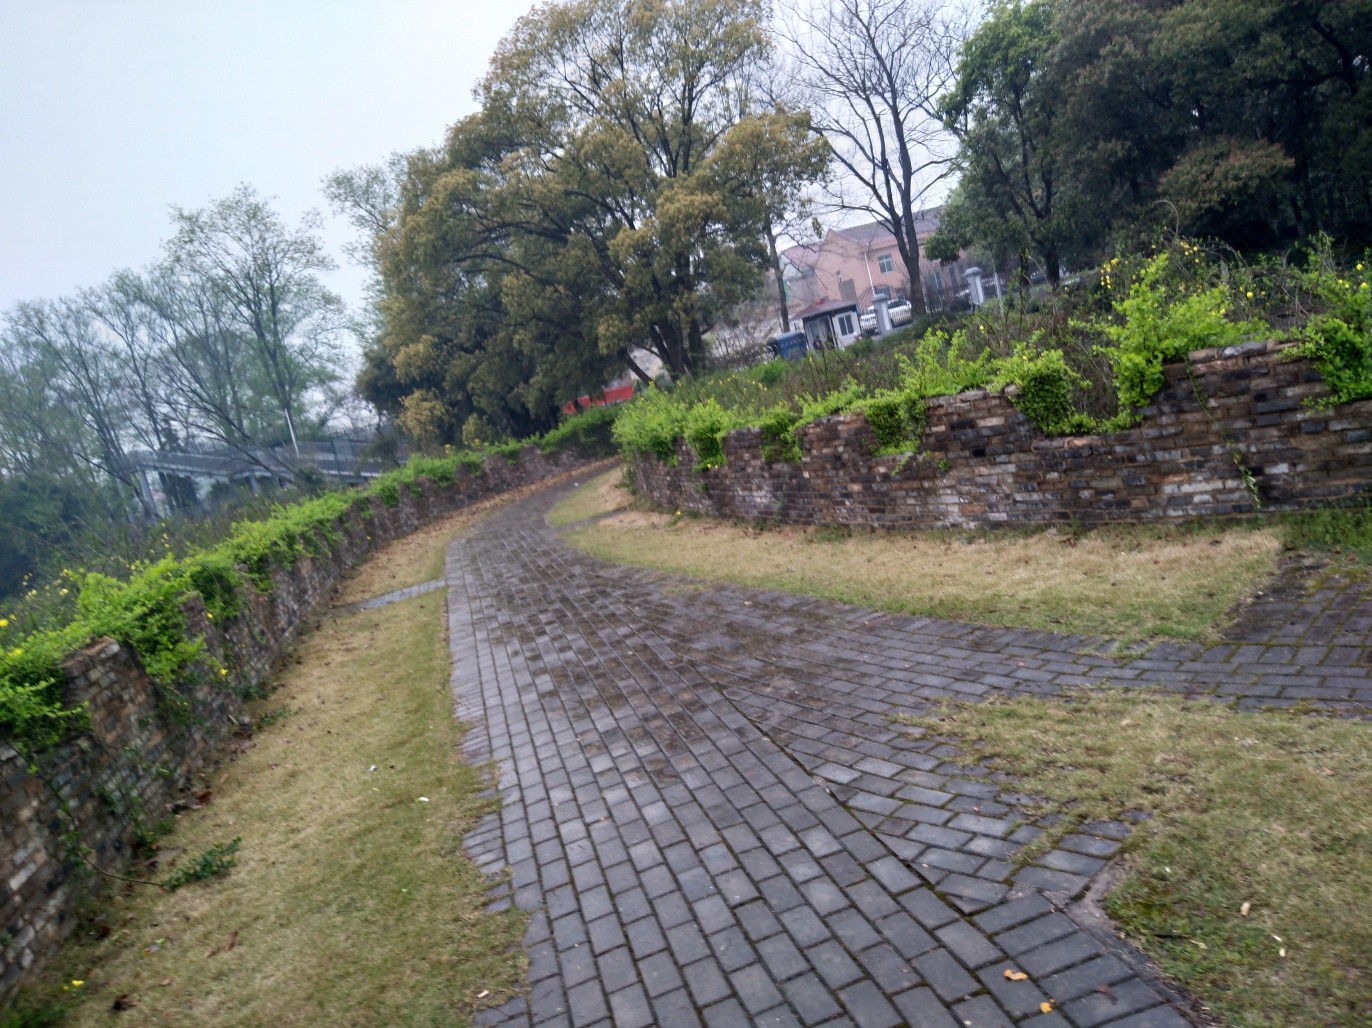What time of year does this image seem to depict, and how can you tell? The image seems to depict either late fall or early spring, as there are some bare trees, which suggests that this is not the peak of summer or the dead of winter. The overcast sky and the lack of snow also imply that it might be a transition season, with the greenery just starting to come back or beginning to turn. 